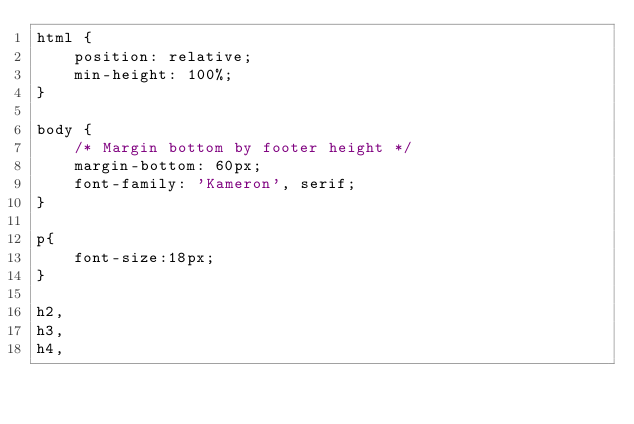Convert code to text. <code><loc_0><loc_0><loc_500><loc_500><_CSS_>html {
    position: relative;
    min-height: 100%;
}

body {
    /* Margin bottom by footer height */
    margin-bottom: 60px;
    font-family: 'Kameron', serif;
}

p{
    font-size:18px;
}

h2,
h3,
h4,</code> 